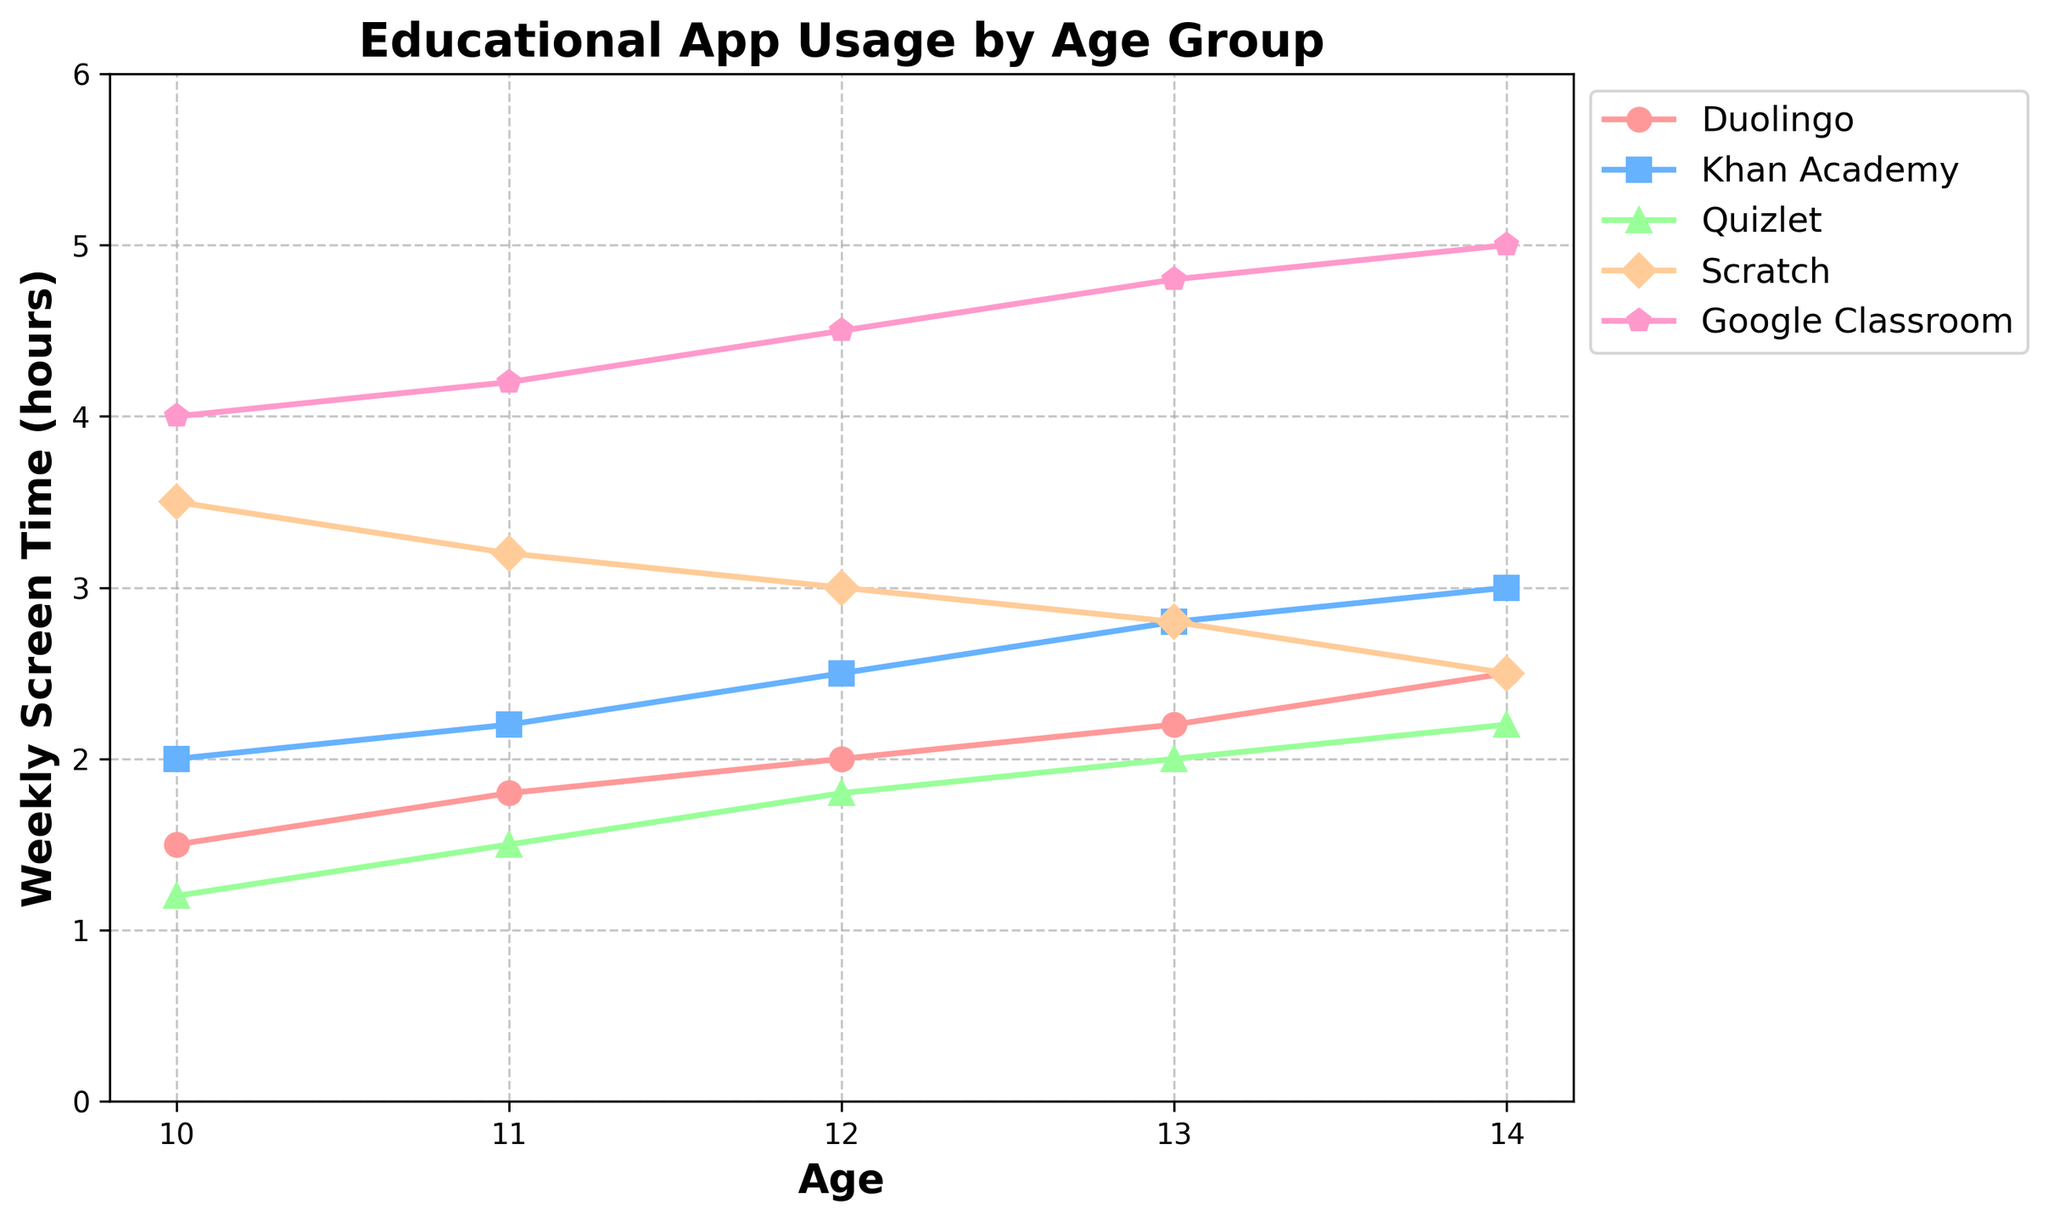What's the average weekly screen time for Khan Academy and Scratch for age 12? To find the average, sum the weekly screen times for both apps at age 12 and divide by 2: (2.5 + 3.0) / 2 = 2.75 hours
Answer: 2.75 hours Which app has the highest usage among 14-year-olds? Look for the highest value in the row corresponding to age 14. Google Classroom has the highest screen time with 5.0 hours.
Answer: Google Classroom How does the screen time for Quizlet compare between ages 10 and 14? Find the screen times for Quizlet at ages 10 and 14 and compare: 1.2 hours for age 10 and 2.2 hours for age 14. The screen time for Quizlet is higher at age 14.
Answer: Higher at age 14 By how much does the screen time for Duolingo increase from age 10 to age 13? Subtract the screen time for Duolingo at age 10 from that at age 13: 2.2 - 1.5 = 0.7 hours
Answer: 0.7 hours Which age group spends the least time on Scratch? Identify the smallest value in the Scratch column: Age 14 has the least screen time at 2.5 hours.
Answer: Age 14 What’s the total weekly screen time for educational apps at age 11? Sum up the weekly screen times for all apps at age 11: 1.8 + 2.2 + 1.5 + 3.2 + 4.2 = 12.9 hours
Answer: 12.9 hours Which app shows the most significant increase in usage from age 11 to age 14? Calculate the difference for each app between ages 11 and 14, then identify the largest increase: 
- Duolingo: 2.5 - 1.8 = 0.7
- Khan Academy: 3.0 - 2.2 = 0.8
- Quizlet: 2.2 - 1.5 = 0.7
- Scratch: 2.5 - 3.2 = -0.7 (decrease)
- Google Classroom: 5.0 - 4.2 = 0.8 The largest increase is a tie between Khan Academy and Google Classroom with 0.8 hours.
Answer: Khan Academy and Google Classroom What is the average total weekly screen time for all ages combined for Duolingo? To find the total screen time for Duolingo at all ages, sum the screen times across all ages and divide by the number of ages: (1.5 + 1.8 + 2.0 + 2.2 + 2.5) / 5 = 2.0 hours
Answer: 2.0 hours 